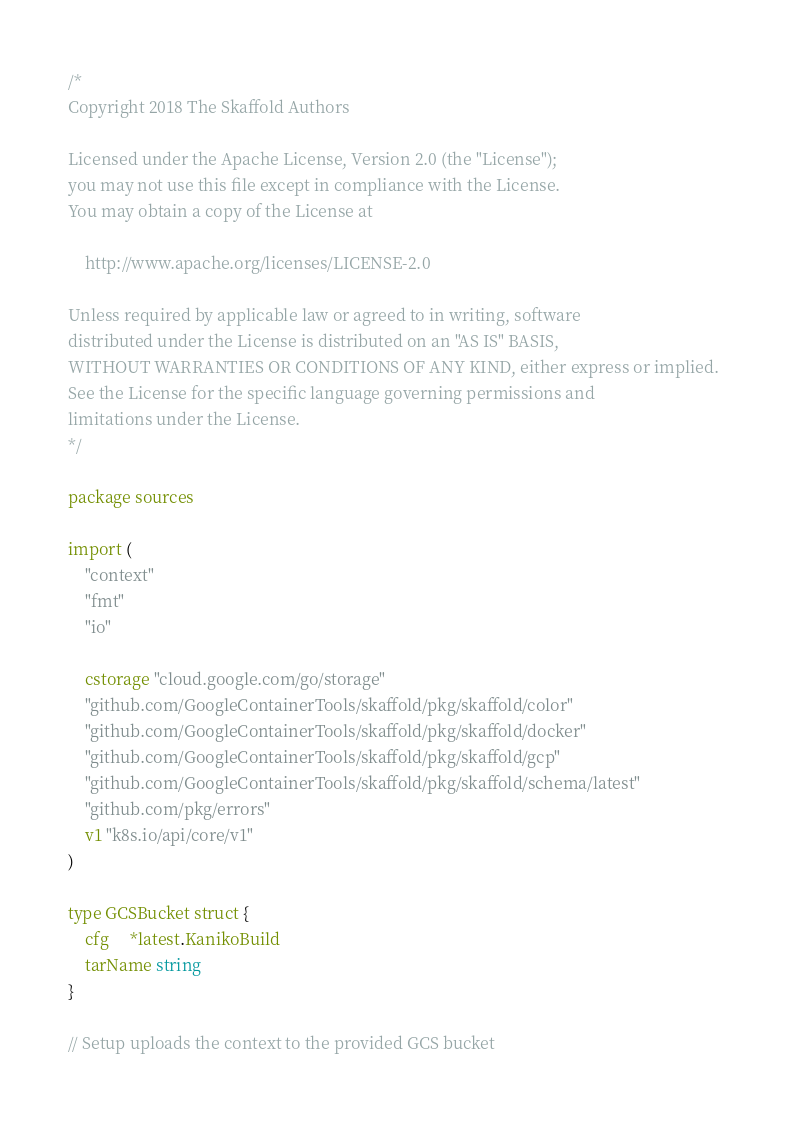Convert code to text. <code><loc_0><loc_0><loc_500><loc_500><_Go_>/*
Copyright 2018 The Skaffold Authors

Licensed under the Apache License, Version 2.0 (the "License");
you may not use this file except in compliance with the License.
You may obtain a copy of the License at

    http://www.apache.org/licenses/LICENSE-2.0

Unless required by applicable law or agreed to in writing, software
distributed under the License is distributed on an "AS IS" BASIS,
WITHOUT WARRANTIES OR CONDITIONS OF ANY KIND, either express or implied.
See the License for the specific language governing permissions and
limitations under the License.
*/

package sources

import (
	"context"
	"fmt"
	"io"

	cstorage "cloud.google.com/go/storage"
	"github.com/GoogleContainerTools/skaffold/pkg/skaffold/color"
	"github.com/GoogleContainerTools/skaffold/pkg/skaffold/docker"
	"github.com/GoogleContainerTools/skaffold/pkg/skaffold/gcp"
	"github.com/GoogleContainerTools/skaffold/pkg/skaffold/schema/latest"
	"github.com/pkg/errors"
	v1 "k8s.io/api/core/v1"
)

type GCSBucket struct {
	cfg     *latest.KanikoBuild
	tarName string
}

// Setup uploads the context to the provided GCS bucket</code> 